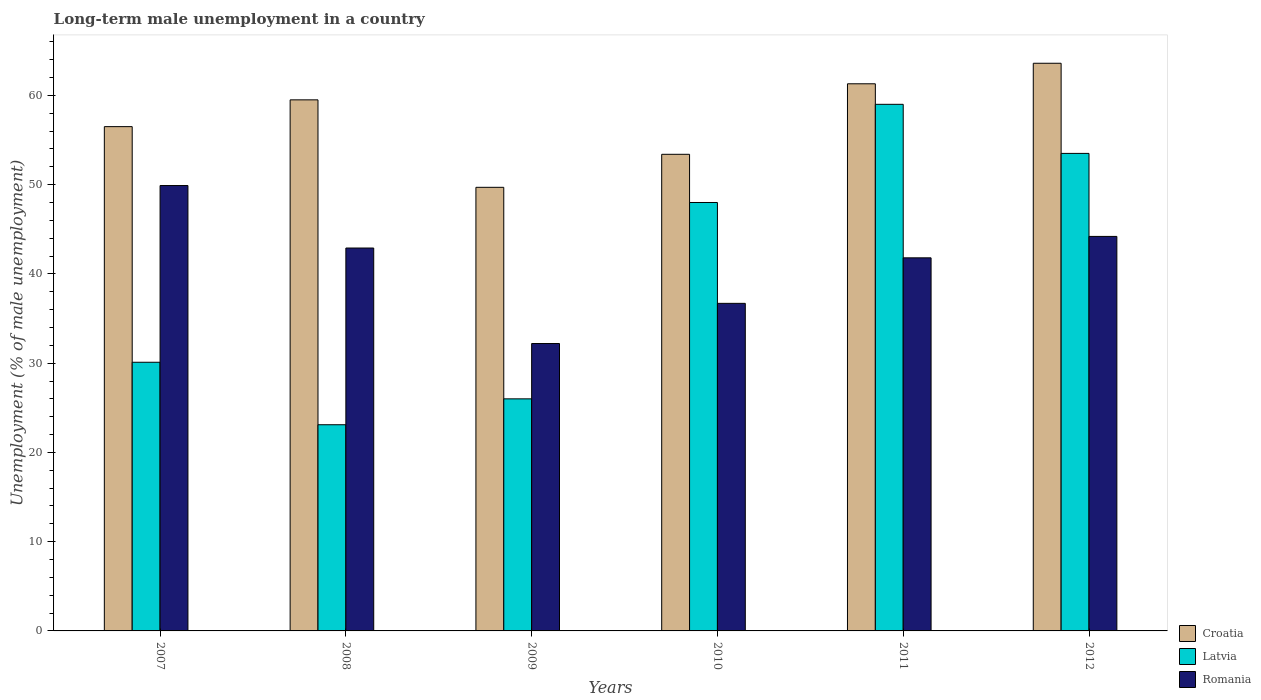How many groups of bars are there?
Provide a short and direct response. 6. Are the number of bars per tick equal to the number of legend labels?
Make the answer very short. Yes. How many bars are there on the 5th tick from the left?
Make the answer very short. 3. How many bars are there on the 3rd tick from the right?
Make the answer very short. 3. What is the label of the 2nd group of bars from the left?
Make the answer very short. 2008. What is the percentage of long-term unemployed male population in Croatia in 2007?
Offer a terse response. 56.5. Across all years, what is the maximum percentage of long-term unemployed male population in Romania?
Make the answer very short. 49.9. Across all years, what is the minimum percentage of long-term unemployed male population in Croatia?
Offer a terse response. 49.7. In which year was the percentage of long-term unemployed male population in Romania maximum?
Offer a terse response. 2007. What is the total percentage of long-term unemployed male population in Romania in the graph?
Offer a very short reply. 247.7. What is the difference between the percentage of long-term unemployed male population in Romania in 2008 and that in 2012?
Keep it short and to the point. -1.3. What is the difference between the percentage of long-term unemployed male population in Latvia in 2007 and the percentage of long-term unemployed male population in Romania in 2012?
Give a very brief answer. -14.1. What is the average percentage of long-term unemployed male population in Latvia per year?
Keep it short and to the point. 39.95. In the year 2010, what is the difference between the percentage of long-term unemployed male population in Romania and percentage of long-term unemployed male population in Latvia?
Your response must be concise. -11.3. In how many years, is the percentage of long-term unemployed male population in Croatia greater than 64 %?
Provide a succinct answer. 0. What is the ratio of the percentage of long-term unemployed male population in Croatia in 2011 to that in 2012?
Provide a short and direct response. 0.96. Is the percentage of long-term unemployed male population in Croatia in 2009 less than that in 2012?
Make the answer very short. Yes. Is the difference between the percentage of long-term unemployed male population in Romania in 2007 and 2010 greater than the difference between the percentage of long-term unemployed male population in Latvia in 2007 and 2010?
Your answer should be very brief. Yes. What is the difference between the highest and the lowest percentage of long-term unemployed male population in Latvia?
Give a very brief answer. 35.9. What does the 1st bar from the left in 2010 represents?
Make the answer very short. Croatia. What does the 3rd bar from the right in 2012 represents?
Provide a succinct answer. Croatia. How many bars are there?
Keep it short and to the point. 18. Are all the bars in the graph horizontal?
Keep it short and to the point. No. How many years are there in the graph?
Ensure brevity in your answer.  6. What is the difference between two consecutive major ticks on the Y-axis?
Provide a short and direct response. 10. Does the graph contain any zero values?
Provide a succinct answer. No. Where does the legend appear in the graph?
Your answer should be very brief. Bottom right. How many legend labels are there?
Offer a terse response. 3. What is the title of the graph?
Keep it short and to the point. Long-term male unemployment in a country. Does "Latin America(developing only)" appear as one of the legend labels in the graph?
Make the answer very short. No. What is the label or title of the X-axis?
Your response must be concise. Years. What is the label or title of the Y-axis?
Provide a succinct answer. Unemployment (% of male unemployment). What is the Unemployment (% of male unemployment) in Croatia in 2007?
Offer a terse response. 56.5. What is the Unemployment (% of male unemployment) of Latvia in 2007?
Your response must be concise. 30.1. What is the Unemployment (% of male unemployment) of Romania in 2007?
Offer a very short reply. 49.9. What is the Unemployment (% of male unemployment) of Croatia in 2008?
Provide a succinct answer. 59.5. What is the Unemployment (% of male unemployment) of Latvia in 2008?
Ensure brevity in your answer.  23.1. What is the Unemployment (% of male unemployment) in Romania in 2008?
Your answer should be compact. 42.9. What is the Unemployment (% of male unemployment) of Croatia in 2009?
Provide a short and direct response. 49.7. What is the Unemployment (% of male unemployment) in Romania in 2009?
Your response must be concise. 32.2. What is the Unemployment (% of male unemployment) of Croatia in 2010?
Provide a short and direct response. 53.4. What is the Unemployment (% of male unemployment) of Latvia in 2010?
Your answer should be compact. 48. What is the Unemployment (% of male unemployment) in Romania in 2010?
Offer a terse response. 36.7. What is the Unemployment (% of male unemployment) in Croatia in 2011?
Offer a very short reply. 61.3. What is the Unemployment (% of male unemployment) in Romania in 2011?
Ensure brevity in your answer.  41.8. What is the Unemployment (% of male unemployment) in Croatia in 2012?
Provide a short and direct response. 63.6. What is the Unemployment (% of male unemployment) in Latvia in 2012?
Make the answer very short. 53.5. What is the Unemployment (% of male unemployment) in Romania in 2012?
Provide a short and direct response. 44.2. Across all years, what is the maximum Unemployment (% of male unemployment) in Croatia?
Offer a terse response. 63.6. Across all years, what is the maximum Unemployment (% of male unemployment) of Romania?
Your answer should be very brief. 49.9. Across all years, what is the minimum Unemployment (% of male unemployment) in Croatia?
Offer a very short reply. 49.7. Across all years, what is the minimum Unemployment (% of male unemployment) in Latvia?
Your answer should be very brief. 23.1. Across all years, what is the minimum Unemployment (% of male unemployment) in Romania?
Give a very brief answer. 32.2. What is the total Unemployment (% of male unemployment) of Croatia in the graph?
Make the answer very short. 344. What is the total Unemployment (% of male unemployment) in Latvia in the graph?
Offer a terse response. 239.7. What is the total Unemployment (% of male unemployment) in Romania in the graph?
Provide a short and direct response. 247.7. What is the difference between the Unemployment (% of male unemployment) of Latvia in 2007 and that in 2008?
Your answer should be very brief. 7. What is the difference between the Unemployment (% of male unemployment) of Latvia in 2007 and that in 2009?
Offer a terse response. 4.1. What is the difference between the Unemployment (% of male unemployment) in Romania in 2007 and that in 2009?
Your answer should be compact. 17.7. What is the difference between the Unemployment (% of male unemployment) in Croatia in 2007 and that in 2010?
Ensure brevity in your answer.  3.1. What is the difference between the Unemployment (% of male unemployment) of Latvia in 2007 and that in 2010?
Make the answer very short. -17.9. What is the difference between the Unemployment (% of male unemployment) of Croatia in 2007 and that in 2011?
Your answer should be compact. -4.8. What is the difference between the Unemployment (% of male unemployment) in Latvia in 2007 and that in 2011?
Keep it short and to the point. -28.9. What is the difference between the Unemployment (% of male unemployment) in Latvia in 2007 and that in 2012?
Offer a very short reply. -23.4. What is the difference between the Unemployment (% of male unemployment) of Croatia in 2008 and that in 2009?
Make the answer very short. 9.8. What is the difference between the Unemployment (% of male unemployment) of Latvia in 2008 and that in 2009?
Provide a succinct answer. -2.9. What is the difference between the Unemployment (% of male unemployment) in Romania in 2008 and that in 2009?
Offer a very short reply. 10.7. What is the difference between the Unemployment (% of male unemployment) of Croatia in 2008 and that in 2010?
Offer a terse response. 6.1. What is the difference between the Unemployment (% of male unemployment) of Latvia in 2008 and that in 2010?
Ensure brevity in your answer.  -24.9. What is the difference between the Unemployment (% of male unemployment) in Romania in 2008 and that in 2010?
Offer a very short reply. 6.2. What is the difference between the Unemployment (% of male unemployment) of Croatia in 2008 and that in 2011?
Your answer should be compact. -1.8. What is the difference between the Unemployment (% of male unemployment) of Latvia in 2008 and that in 2011?
Your answer should be very brief. -35.9. What is the difference between the Unemployment (% of male unemployment) of Latvia in 2008 and that in 2012?
Provide a short and direct response. -30.4. What is the difference between the Unemployment (% of male unemployment) of Romania in 2008 and that in 2012?
Offer a very short reply. -1.3. What is the difference between the Unemployment (% of male unemployment) of Romania in 2009 and that in 2010?
Ensure brevity in your answer.  -4.5. What is the difference between the Unemployment (% of male unemployment) in Latvia in 2009 and that in 2011?
Keep it short and to the point. -33. What is the difference between the Unemployment (% of male unemployment) in Latvia in 2009 and that in 2012?
Your answer should be compact. -27.5. What is the difference between the Unemployment (% of male unemployment) in Latvia in 2010 and that in 2011?
Your answer should be very brief. -11. What is the difference between the Unemployment (% of male unemployment) in Romania in 2010 and that in 2011?
Your response must be concise. -5.1. What is the difference between the Unemployment (% of male unemployment) in Croatia in 2010 and that in 2012?
Provide a succinct answer. -10.2. What is the difference between the Unemployment (% of male unemployment) of Latvia in 2010 and that in 2012?
Provide a short and direct response. -5.5. What is the difference between the Unemployment (% of male unemployment) of Romania in 2010 and that in 2012?
Provide a succinct answer. -7.5. What is the difference between the Unemployment (% of male unemployment) in Croatia in 2011 and that in 2012?
Offer a terse response. -2.3. What is the difference between the Unemployment (% of male unemployment) of Latvia in 2011 and that in 2012?
Your response must be concise. 5.5. What is the difference between the Unemployment (% of male unemployment) of Romania in 2011 and that in 2012?
Your answer should be compact. -2.4. What is the difference between the Unemployment (% of male unemployment) of Croatia in 2007 and the Unemployment (% of male unemployment) of Latvia in 2008?
Ensure brevity in your answer.  33.4. What is the difference between the Unemployment (% of male unemployment) of Croatia in 2007 and the Unemployment (% of male unemployment) of Romania in 2008?
Make the answer very short. 13.6. What is the difference between the Unemployment (% of male unemployment) in Croatia in 2007 and the Unemployment (% of male unemployment) in Latvia in 2009?
Give a very brief answer. 30.5. What is the difference between the Unemployment (% of male unemployment) in Croatia in 2007 and the Unemployment (% of male unemployment) in Romania in 2009?
Ensure brevity in your answer.  24.3. What is the difference between the Unemployment (% of male unemployment) of Latvia in 2007 and the Unemployment (% of male unemployment) of Romania in 2009?
Provide a short and direct response. -2.1. What is the difference between the Unemployment (% of male unemployment) of Croatia in 2007 and the Unemployment (% of male unemployment) of Latvia in 2010?
Provide a succinct answer. 8.5. What is the difference between the Unemployment (% of male unemployment) of Croatia in 2007 and the Unemployment (% of male unemployment) of Romania in 2010?
Keep it short and to the point. 19.8. What is the difference between the Unemployment (% of male unemployment) of Latvia in 2007 and the Unemployment (% of male unemployment) of Romania in 2010?
Give a very brief answer. -6.6. What is the difference between the Unemployment (% of male unemployment) in Croatia in 2007 and the Unemployment (% of male unemployment) in Latvia in 2011?
Offer a very short reply. -2.5. What is the difference between the Unemployment (% of male unemployment) of Latvia in 2007 and the Unemployment (% of male unemployment) of Romania in 2011?
Offer a terse response. -11.7. What is the difference between the Unemployment (% of male unemployment) of Latvia in 2007 and the Unemployment (% of male unemployment) of Romania in 2012?
Make the answer very short. -14.1. What is the difference between the Unemployment (% of male unemployment) of Croatia in 2008 and the Unemployment (% of male unemployment) of Latvia in 2009?
Offer a very short reply. 33.5. What is the difference between the Unemployment (% of male unemployment) of Croatia in 2008 and the Unemployment (% of male unemployment) of Romania in 2009?
Provide a succinct answer. 27.3. What is the difference between the Unemployment (% of male unemployment) in Latvia in 2008 and the Unemployment (% of male unemployment) in Romania in 2009?
Your response must be concise. -9.1. What is the difference between the Unemployment (% of male unemployment) of Croatia in 2008 and the Unemployment (% of male unemployment) of Romania in 2010?
Your response must be concise. 22.8. What is the difference between the Unemployment (% of male unemployment) of Croatia in 2008 and the Unemployment (% of male unemployment) of Latvia in 2011?
Ensure brevity in your answer.  0.5. What is the difference between the Unemployment (% of male unemployment) of Latvia in 2008 and the Unemployment (% of male unemployment) of Romania in 2011?
Provide a succinct answer. -18.7. What is the difference between the Unemployment (% of male unemployment) of Croatia in 2008 and the Unemployment (% of male unemployment) of Latvia in 2012?
Ensure brevity in your answer.  6. What is the difference between the Unemployment (% of male unemployment) of Latvia in 2008 and the Unemployment (% of male unemployment) of Romania in 2012?
Your answer should be very brief. -21.1. What is the difference between the Unemployment (% of male unemployment) of Croatia in 2009 and the Unemployment (% of male unemployment) of Latvia in 2010?
Your response must be concise. 1.7. What is the difference between the Unemployment (% of male unemployment) of Latvia in 2009 and the Unemployment (% of male unemployment) of Romania in 2011?
Make the answer very short. -15.8. What is the difference between the Unemployment (% of male unemployment) in Croatia in 2009 and the Unemployment (% of male unemployment) in Latvia in 2012?
Provide a succinct answer. -3.8. What is the difference between the Unemployment (% of male unemployment) in Croatia in 2009 and the Unemployment (% of male unemployment) in Romania in 2012?
Make the answer very short. 5.5. What is the difference between the Unemployment (% of male unemployment) in Latvia in 2009 and the Unemployment (% of male unemployment) in Romania in 2012?
Give a very brief answer. -18.2. What is the difference between the Unemployment (% of male unemployment) in Latvia in 2010 and the Unemployment (% of male unemployment) in Romania in 2011?
Your answer should be compact. 6.2. What is the difference between the Unemployment (% of male unemployment) in Croatia in 2011 and the Unemployment (% of male unemployment) in Latvia in 2012?
Your response must be concise. 7.8. What is the difference between the Unemployment (% of male unemployment) of Croatia in 2011 and the Unemployment (% of male unemployment) of Romania in 2012?
Your answer should be very brief. 17.1. What is the difference between the Unemployment (% of male unemployment) in Latvia in 2011 and the Unemployment (% of male unemployment) in Romania in 2012?
Offer a terse response. 14.8. What is the average Unemployment (% of male unemployment) in Croatia per year?
Give a very brief answer. 57.33. What is the average Unemployment (% of male unemployment) of Latvia per year?
Your response must be concise. 39.95. What is the average Unemployment (% of male unemployment) of Romania per year?
Provide a succinct answer. 41.28. In the year 2007, what is the difference between the Unemployment (% of male unemployment) in Croatia and Unemployment (% of male unemployment) in Latvia?
Provide a short and direct response. 26.4. In the year 2007, what is the difference between the Unemployment (% of male unemployment) in Croatia and Unemployment (% of male unemployment) in Romania?
Your answer should be compact. 6.6. In the year 2007, what is the difference between the Unemployment (% of male unemployment) of Latvia and Unemployment (% of male unemployment) of Romania?
Offer a terse response. -19.8. In the year 2008, what is the difference between the Unemployment (% of male unemployment) of Croatia and Unemployment (% of male unemployment) of Latvia?
Give a very brief answer. 36.4. In the year 2008, what is the difference between the Unemployment (% of male unemployment) in Croatia and Unemployment (% of male unemployment) in Romania?
Your response must be concise. 16.6. In the year 2008, what is the difference between the Unemployment (% of male unemployment) in Latvia and Unemployment (% of male unemployment) in Romania?
Make the answer very short. -19.8. In the year 2009, what is the difference between the Unemployment (% of male unemployment) of Croatia and Unemployment (% of male unemployment) of Latvia?
Make the answer very short. 23.7. In the year 2009, what is the difference between the Unemployment (% of male unemployment) in Croatia and Unemployment (% of male unemployment) in Romania?
Your answer should be very brief. 17.5. In the year 2010, what is the difference between the Unemployment (% of male unemployment) of Croatia and Unemployment (% of male unemployment) of Latvia?
Offer a terse response. 5.4. In the year 2010, what is the difference between the Unemployment (% of male unemployment) of Croatia and Unemployment (% of male unemployment) of Romania?
Keep it short and to the point. 16.7. In the year 2011, what is the difference between the Unemployment (% of male unemployment) of Croatia and Unemployment (% of male unemployment) of Romania?
Offer a terse response. 19.5. In the year 2012, what is the difference between the Unemployment (% of male unemployment) of Croatia and Unemployment (% of male unemployment) of Latvia?
Ensure brevity in your answer.  10.1. In the year 2012, what is the difference between the Unemployment (% of male unemployment) in Croatia and Unemployment (% of male unemployment) in Romania?
Offer a very short reply. 19.4. What is the ratio of the Unemployment (% of male unemployment) of Croatia in 2007 to that in 2008?
Your answer should be compact. 0.95. What is the ratio of the Unemployment (% of male unemployment) in Latvia in 2007 to that in 2008?
Provide a short and direct response. 1.3. What is the ratio of the Unemployment (% of male unemployment) in Romania in 2007 to that in 2008?
Provide a short and direct response. 1.16. What is the ratio of the Unemployment (% of male unemployment) in Croatia in 2007 to that in 2009?
Offer a very short reply. 1.14. What is the ratio of the Unemployment (% of male unemployment) in Latvia in 2007 to that in 2009?
Ensure brevity in your answer.  1.16. What is the ratio of the Unemployment (% of male unemployment) in Romania in 2007 to that in 2009?
Offer a very short reply. 1.55. What is the ratio of the Unemployment (% of male unemployment) of Croatia in 2007 to that in 2010?
Keep it short and to the point. 1.06. What is the ratio of the Unemployment (% of male unemployment) in Latvia in 2007 to that in 2010?
Your answer should be very brief. 0.63. What is the ratio of the Unemployment (% of male unemployment) of Romania in 2007 to that in 2010?
Your response must be concise. 1.36. What is the ratio of the Unemployment (% of male unemployment) in Croatia in 2007 to that in 2011?
Provide a short and direct response. 0.92. What is the ratio of the Unemployment (% of male unemployment) of Latvia in 2007 to that in 2011?
Your answer should be very brief. 0.51. What is the ratio of the Unemployment (% of male unemployment) of Romania in 2007 to that in 2011?
Make the answer very short. 1.19. What is the ratio of the Unemployment (% of male unemployment) in Croatia in 2007 to that in 2012?
Your answer should be compact. 0.89. What is the ratio of the Unemployment (% of male unemployment) of Latvia in 2007 to that in 2012?
Your answer should be very brief. 0.56. What is the ratio of the Unemployment (% of male unemployment) in Romania in 2007 to that in 2012?
Make the answer very short. 1.13. What is the ratio of the Unemployment (% of male unemployment) in Croatia in 2008 to that in 2009?
Offer a terse response. 1.2. What is the ratio of the Unemployment (% of male unemployment) in Latvia in 2008 to that in 2009?
Your answer should be compact. 0.89. What is the ratio of the Unemployment (% of male unemployment) in Romania in 2008 to that in 2009?
Your answer should be compact. 1.33. What is the ratio of the Unemployment (% of male unemployment) in Croatia in 2008 to that in 2010?
Offer a very short reply. 1.11. What is the ratio of the Unemployment (% of male unemployment) of Latvia in 2008 to that in 2010?
Offer a terse response. 0.48. What is the ratio of the Unemployment (% of male unemployment) in Romania in 2008 to that in 2010?
Your answer should be very brief. 1.17. What is the ratio of the Unemployment (% of male unemployment) of Croatia in 2008 to that in 2011?
Offer a terse response. 0.97. What is the ratio of the Unemployment (% of male unemployment) in Latvia in 2008 to that in 2011?
Provide a succinct answer. 0.39. What is the ratio of the Unemployment (% of male unemployment) in Romania in 2008 to that in 2011?
Ensure brevity in your answer.  1.03. What is the ratio of the Unemployment (% of male unemployment) of Croatia in 2008 to that in 2012?
Make the answer very short. 0.94. What is the ratio of the Unemployment (% of male unemployment) in Latvia in 2008 to that in 2012?
Ensure brevity in your answer.  0.43. What is the ratio of the Unemployment (% of male unemployment) in Romania in 2008 to that in 2012?
Offer a very short reply. 0.97. What is the ratio of the Unemployment (% of male unemployment) of Croatia in 2009 to that in 2010?
Your answer should be compact. 0.93. What is the ratio of the Unemployment (% of male unemployment) in Latvia in 2009 to that in 2010?
Keep it short and to the point. 0.54. What is the ratio of the Unemployment (% of male unemployment) in Romania in 2009 to that in 2010?
Your answer should be compact. 0.88. What is the ratio of the Unemployment (% of male unemployment) of Croatia in 2009 to that in 2011?
Your response must be concise. 0.81. What is the ratio of the Unemployment (% of male unemployment) in Latvia in 2009 to that in 2011?
Offer a very short reply. 0.44. What is the ratio of the Unemployment (% of male unemployment) in Romania in 2009 to that in 2011?
Give a very brief answer. 0.77. What is the ratio of the Unemployment (% of male unemployment) in Croatia in 2009 to that in 2012?
Your answer should be compact. 0.78. What is the ratio of the Unemployment (% of male unemployment) of Latvia in 2009 to that in 2012?
Ensure brevity in your answer.  0.49. What is the ratio of the Unemployment (% of male unemployment) in Romania in 2009 to that in 2012?
Provide a short and direct response. 0.73. What is the ratio of the Unemployment (% of male unemployment) in Croatia in 2010 to that in 2011?
Your response must be concise. 0.87. What is the ratio of the Unemployment (% of male unemployment) in Latvia in 2010 to that in 2011?
Keep it short and to the point. 0.81. What is the ratio of the Unemployment (% of male unemployment) of Romania in 2010 to that in 2011?
Your response must be concise. 0.88. What is the ratio of the Unemployment (% of male unemployment) of Croatia in 2010 to that in 2012?
Offer a terse response. 0.84. What is the ratio of the Unemployment (% of male unemployment) of Latvia in 2010 to that in 2012?
Ensure brevity in your answer.  0.9. What is the ratio of the Unemployment (% of male unemployment) of Romania in 2010 to that in 2012?
Offer a very short reply. 0.83. What is the ratio of the Unemployment (% of male unemployment) in Croatia in 2011 to that in 2012?
Your answer should be very brief. 0.96. What is the ratio of the Unemployment (% of male unemployment) in Latvia in 2011 to that in 2012?
Your response must be concise. 1.1. What is the ratio of the Unemployment (% of male unemployment) in Romania in 2011 to that in 2012?
Give a very brief answer. 0.95. What is the difference between the highest and the second highest Unemployment (% of male unemployment) of Croatia?
Keep it short and to the point. 2.3. What is the difference between the highest and the second highest Unemployment (% of male unemployment) in Latvia?
Give a very brief answer. 5.5. What is the difference between the highest and the second highest Unemployment (% of male unemployment) of Romania?
Offer a terse response. 5.7. What is the difference between the highest and the lowest Unemployment (% of male unemployment) in Croatia?
Ensure brevity in your answer.  13.9. What is the difference between the highest and the lowest Unemployment (% of male unemployment) of Latvia?
Make the answer very short. 35.9. What is the difference between the highest and the lowest Unemployment (% of male unemployment) of Romania?
Offer a very short reply. 17.7. 